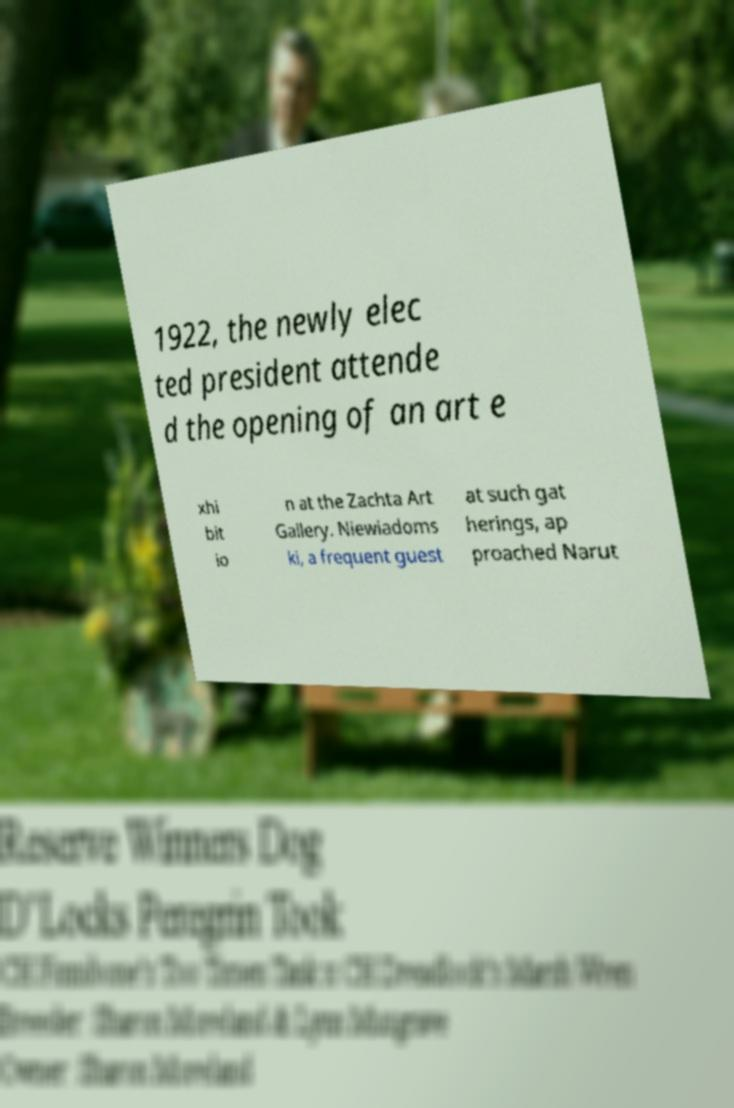I need the written content from this picture converted into text. Can you do that? 1922, the newly elec ted president attende d the opening of an art e xhi bit io n at the Zachta Art Gallery. Niewiadoms ki, a frequent guest at such gat herings, ap proached Narut 